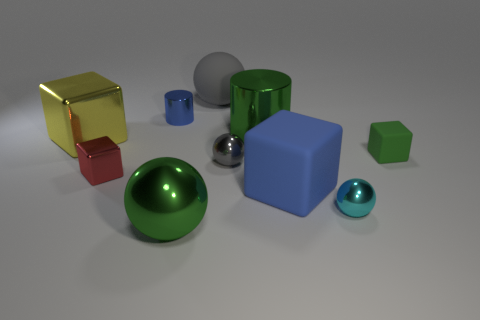Are there any small brown shiny things that have the same shape as the tiny blue thing?
Ensure brevity in your answer.  No. The small red metal thing has what shape?
Provide a short and direct response. Cube. What material is the small sphere that is in front of the big rubber thing that is on the right side of the sphere that is behind the small blue cylinder?
Offer a terse response. Metal. Are there more small green things that are right of the big yellow cube than large rubber things?
Offer a very short reply. No. What is the material of the cyan thing that is the same size as the blue metallic thing?
Offer a terse response. Metal. Is there a matte object that has the same size as the yellow metallic thing?
Your response must be concise. Yes. What size is the matte object that is in front of the red metallic object?
Keep it short and to the point. Large. The red cube is what size?
Make the answer very short. Small. What number of balls are either green metal things or large blue objects?
Provide a succinct answer. 1. What is the size of the gray object that is made of the same material as the large blue block?
Give a very brief answer. Large. 